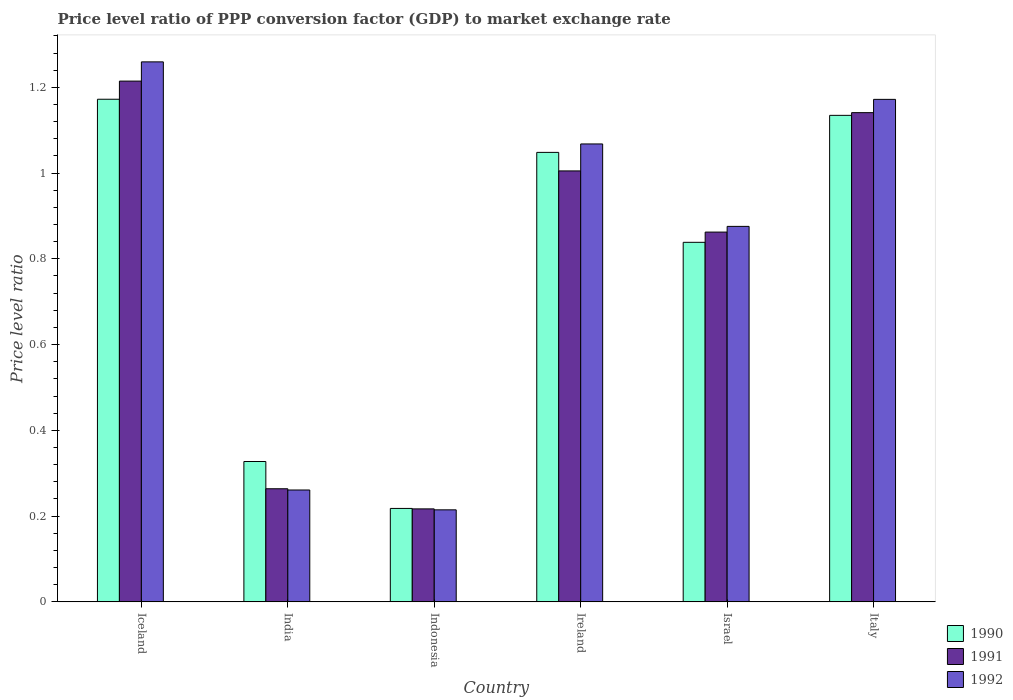How many groups of bars are there?
Provide a short and direct response. 6. Are the number of bars per tick equal to the number of legend labels?
Your response must be concise. Yes. Are the number of bars on each tick of the X-axis equal?
Your answer should be very brief. Yes. How many bars are there on the 4th tick from the right?
Offer a terse response. 3. What is the label of the 4th group of bars from the left?
Give a very brief answer. Ireland. In how many cases, is the number of bars for a given country not equal to the number of legend labels?
Provide a succinct answer. 0. What is the price level ratio in 1991 in Iceland?
Ensure brevity in your answer.  1.21. Across all countries, what is the maximum price level ratio in 1991?
Offer a very short reply. 1.21. Across all countries, what is the minimum price level ratio in 1991?
Provide a short and direct response. 0.22. In which country was the price level ratio in 1992 maximum?
Your response must be concise. Iceland. In which country was the price level ratio in 1992 minimum?
Your answer should be compact. Indonesia. What is the total price level ratio in 1990 in the graph?
Keep it short and to the point. 4.74. What is the difference between the price level ratio in 1991 in Indonesia and that in Ireland?
Make the answer very short. -0.79. What is the difference between the price level ratio in 1990 in Israel and the price level ratio in 1992 in Indonesia?
Your answer should be very brief. 0.62. What is the average price level ratio in 1992 per country?
Your answer should be very brief. 0.81. What is the difference between the price level ratio of/in 1992 and price level ratio of/in 1991 in Ireland?
Offer a terse response. 0.06. In how many countries, is the price level ratio in 1991 greater than 0.7200000000000001?
Offer a terse response. 4. What is the ratio of the price level ratio in 1990 in Ireland to that in Italy?
Offer a very short reply. 0.92. Is the price level ratio in 1991 in Ireland less than that in Italy?
Provide a short and direct response. Yes. What is the difference between the highest and the second highest price level ratio in 1992?
Offer a terse response. 0.19. What is the difference between the highest and the lowest price level ratio in 1992?
Make the answer very short. 1.04. In how many countries, is the price level ratio in 1990 greater than the average price level ratio in 1990 taken over all countries?
Make the answer very short. 4. What does the 2nd bar from the left in Iceland represents?
Provide a short and direct response. 1991. What does the 3rd bar from the right in Italy represents?
Offer a very short reply. 1990. Is it the case that in every country, the sum of the price level ratio in 1991 and price level ratio in 1992 is greater than the price level ratio in 1990?
Ensure brevity in your answer.  Yes. How many bars are there?
Your answer should be compact. 18. Are all the bars in the graph horizontal?
Make the answer very short. No. What is the difference between two consecutive major ticks on the Y-axis?
Your answer should be compact. 0.2. Are the values on the major ticks of Y-axis written in scientific E-notation?
Give a very brief answer. No. Does the graph contain grids?
Keep it short and to the point. No. How many legend labels are there?
Offer a very short reply. 3. How are the legend labels stacked?
Offer a terse response. Vertical. What is the title of the graph?
Keep it short and to the point. Price level ratio of PPP conversion factor (GDP) to market exchange rate. What is the label or title of the Y-axis?
Make the answer very short. Price level ratio. What is the Price level ratio of 1990 in Iceland?
Provide a short and direct response. 1.17. What is the Price level ratio of 1991 in Iceland?
Provide a short and direct response. 1.21. What is the Price level ratio in 1992 in Iceland?
Offer a very short reply. 1.26. What is the Price level ratio of 1990 in India?
Make the answer very short. 0.33. What is the Price level ratio in 1991 in India?
Offer a terse response. 0.26. What is the Price level ratio of 1992 in India?
Make the answer very short. 0.26. What is the Price level ratio in 1990 in Indonesia?
Your response must be concise. 0.22. What is the Price level ratio of 1991 in Indonesia?
Your response must be concise. 0.22. What is the Price level ratio of 1992 in Indonesia?
Provide a succinct answer. 0.21. What is the Price level ratio of 1990 in Ireland?
Give a very brief answer. 1.05. What is the Price level ratio in 1991 in Ireland?
Ensure brevity in your answer.  1.01. What is the Price level ratio of 1992 in Ireland?
Offer a very short reply. 1.07. What is the Price level ratio of 1990 in Israel?
Give a very brief answer. 0.84. What is the Price level ratio in 1991 in Israel?
Give a very brief answer. 0.86. What is the Price level ratio of 1992 in Israel?
Provide a succinct answer. 0.88. What is the Price level ratio of 1990 in Italy?
Provide a succinct answer. 1.13. What is the Price level ratio in 1991 in Italy?
Your answer should be very brief. 1.14. What is the Price level ratio of 1992 in Italy?
Your response must be concise. 1.17. Across all countries, what is the maximum Price level ratio of 1990?
Give a very brief answer. 1.17. Across all countries, what is the maximum Price level ratio in 1991?
Your answer should be very brief. 1.21. Across all countries, what is the maximum Price level ratio in 1992?
Keep it short and to the point. 1.26. Across all countries, what is the minimum Price level ratio in 1990?
Make the answer very short. 0.22. Across all countries, what is the minimum Price level ratio in 1991?
Keep it short and to the point. 0.22. Across all countries, what is the minimum Price level ratio of 1992?
Your answer should be compact. 0.21. What is the total Price level ratio of 1990 in the graph?
Provide a short and direct response. 4.74. What is the total Price level ratio of 1991 in the graph?
Your answer should be very brief. 4.7. What is the total Price level ratio in 1992 in the graph?
Provide a succinct answer. 4.85. What is the difference between the Price level ratio of 1990 in Iceland and that in India?
Keep it short and to the point. 0.84. What is the difference between the Price level ratio in 1991 in Iceland and that in India?
Offer a terse response. 0.95. What is the difference between the Price level ratio of 1992 in Iceland and that in India?
Ensure brevity in your answer.  1. What is the difference between the Price level ratio in 1990 in Iceland and that in Indonesia?
Make the answer very short. 0.95. What is the difference between the Price level ratio of 1992 in Iceland and that in Indonesia?
Make the answer very short. 1.04. What is the difference between the Price level ratio of 1990 in Iceland and that in Ireland?
Your response must be concise. 0.12. What is the difference between the Price level ratio in 1991 in Iceland and that in Ireland?
Keep it short and to the point. 0.21. What is the difference between the Price level ratio of 1992 in Iceland and that in Ireland?
Ensure brevity in your answer.  0.19. What is the difference between the Price level ratio in 1990 in Iceland and that in Israel?
Ensure brevity in your answer.  0.33. What is the difference between the Price level ratio in 1991 in Iceland and that in Israel?
Your answer should be very brief. 0.35. What is the difference between the Price level ratio in 1992 in Iceland and that in Israel?
Provide a succinct answer. 0.38. What is the difference between the Price level ratio of 1990 in Iceland and that in Italy?
Make the answer very short. 0.04. What is the difference between the Price level ratio of 1991 in Iceland and that in Italy?
Provide a short and direct response. 0.07. What is the difference between the Price level ratio in 1992 in Iceland and that in Italy?
Offer a very short reply. 0.09. What is the difference between the Price level ratio of 1990 in India and that in Indonesia?
Keep it short and to the point. 0.11. What is the difference between the Price level ratio of 1991 in India and that in Indonesia?
Your response must be concise. 0.05. What is the difference between the Price level ratio of 1992 in India and that in Indonesia?
Ensure brevity in your answer.  0.05. What is the difference between the Price level ratio of 1990 in India and that in Ireland?
Your answer should be very brief. -0.72. What is the difference between the Price level ratio of 1991 in India and that in Ireland?
Offer a very short reply. -0.74. What is the difference between the Price level ratio in 1992 in India and that in Ireland?
Your answer should be compact. -0.81. What is the difference between the Price level ratio in 1990 in India and that in Israel?
Keep it short and to the point. -0.51. What is the difference between the Price level ratio of 1991 in India and that in Israel?
Your answer should be very brief. -0.6. What is the difference between the Price level ratio of 1992 in India and that in Israel?
Provide a short and direct response. -0.61. What is the difference between the Price level ratio in 1990 in India and that in Italy?
Offer a very short reply. -0.81. What is the difference between the Price level ratio in 1991 in India and that in Italy?
Give a very brief answer. -0.88. What is the difference between the Price level ratio in 1992 in India and that in Italy?
Make the answer very short. -0.91. What is the difference between the Price level ratio in 1990 in Indonesia and that in Ireland?
Your answer should be very brief. -0.83. What is the difference between the Price level ratio in 1991 in Indonesia and that in Ireland?
Give a very brief answer. -0.79. What is the difference between the Price level ratio in 1992 in Indonesia and that in Ireland?
Offer a very short reply. -0.85. What is the difference between the Price level ratio in 1990 in Indonesia and that in Israel?
Offer a very short reply. -0.62. What is the difference between the Price level ratio of 1991 in Indonesia and that in Israel?
Keep it short and to the point. -0.65. What is the difference between the Price level ratio of 1992 in Indonesia and that in Israel?
Your answer should be very brief. -0.66. What is the difference between the Price level ratio in 1990 in Indonesia and that in Italy?
Give a very brief answer. -0.92. What is the difference between the Price level ratio in 1991 in Indonesia and that in Italy?
Keep it short and to the point. -0.92. What is the difference between the Price level ratio in 1992 in Indonesia and that in Italy?
Keep it short and to the point. -0.96. What is the difference between the Price level ratio in 1990 in Ireland and that in Israel?
Make the answer very short. 0.21. What is the difference between the Price level ratio of 1991 in Ireland and that in Israel?
Offer a terse response. 0.14. What is the difference between the Price level ratio in 1992 in Ireland and that in Israel?
Offer a very short reply. 0.19. What is the difference between the Price level ratio of 1990 in Ireland and that in Italy?
Offer a very short reply. -0.09. What is the difference between the Price level ratio of 1991 in Ireland and that in Italy?
Give a very brief answer. -0.14. What is the difference between the Price level ratio of 1992 in Ireland and that in Italy?
Provide a succinct answer. -0.1. What is the difference between the Price level ratio of 1990 in Israel and that in Italy?
Ensure brevity in your answer.  -0.3. What is the difference between the Price level ratio of 1991 in Israel and that in Italy?
Keep it short and to the point. -0.28. What is the difference between the Price level ratio of 1992 in Israel and that in Italy?
Offer a terse response. -0.3. What is the difference between the Price level ratio in 1990 in Iceland and the Price level ratio in 1991 in India?
Offer a terse response. 0.91. What is the difference between the Price level ratio in 1990 in Iceland and the Price level ratio in 1992 in India?
Offer a terse response. 0.91. What is the difference between the Price level ratio in 1991 in Iceland and the Price level ratio in 1992 in India?
Provide a short and direct response. 0.95. What is the difference between the Price level ratio of 1990 in Iceland and the Price level ratio of 1991 in Indonesia?
Provide a short and direct response. 0.96. What is the difference between the Price level ratio in 1990 in Iceland and the Price level ratio in 1992 in Indonesia?
Ensure brevity in your answer.  0.96. What is the difference between the Price level ratio of 1991 in Iceland and the Price level ratio of 1992 in Indonesia?
Provide a succinct answer. 1. What is the difference between the Price level ratio of 1990 in Iceland and the Price level ratio of 1991 in Ireland?
Your answer should be compact. 0.17. What is the difference between the Price level ratio in 1990 in Iceland and the Price level ratio in 1992 in Ireland?
Give a very brief answer. 0.1. What is the difference between the Price level ratio of 1991 in Iceland and the Price level ratio of 1992 in Ireland?
Your answer should be compact. 0.15. What is the difference between the Price level ratio of 1990 in Iceland and the Price level ratio of 1991 in Israel?
Your answer should be compact. 0.31. What is the difference between the Price level ratio of 1990 in Iceland and the Price level ratio of 1992 in Israel?
Ensure brevity in your answer.  0.3. What is the difference between the Price level ratio in 1991 in Iceland and the Price level ratio in 1992 in Israel?
Ensure brevity in your answer.  0.34. What is the difference between the Price level ratio of 1990 in Iceland and the Price level ratio of 1991 in Italy?
Your answer should be compact. 0.03. What is the difference between the Price level ratio of 1990 in Iceland and the Price level ratio of 1992 in Italy?
Make the answer very short. 0. What is the difference between the Price level ratio of 1991 in Iceland and the Price level ratio of 1992 in Italy?
Make the answer very short. 0.04. What is the difference between the Price level ratio in 1990 in India and the Price level ratio in 1991 in Indonesia?
Offer a very short reply. 0.11. What is the difference between the Price level ratio of 1990 in India and the Price level ratio of 1992 in Indonesia?
Provide a short and direct response. 0.11. What is the difference between the Price level ratio of 1991 in India and the Price level ratio of 1992 in Indonesia?
Provide a succinct answer. 0.05. What is the difference between the Price level ratio of 1990 in India and the Price level ratio of 1991 in Ireland?
Provide a short and direct response. -0.68. What is the difference between the Price level ratio of 1990 in India and the Price level ratio of 1992 in Ireland?
Offer a very short reply. -0.74. What is the difference between the Price level ratio in 1991 in India and the Price level ratio in 1992 in Ireland?
Your response must be concise. -0.8. What is the difference between the Price level ratio in 1990 in India and the Price level ratio in 1991 in Israel?
Make the answer very short. -0.54. What is the difference between the Price level ratio of 1990 in India and the Price level ratio of 1992 in Israel?
Keep it short and to the point. -0.55. What is the difference between the Price level ratio of 1991 in India and the Price level ratio of 1992 in Israel?
Your response must be concise. -0.61. What is the difference between the Price level ratio in 1990 in India and the Price level ratio in 1991 in Italy?
Your response must be concise. -0.81. What is the difference between the Price level ratio of 1990 in India and the Price level ratio of 1992 in Italy?
Give a very brief answer. -0.84. What is the difference between the Price level ratio in 1991 in India and the Price level ratio in 1992 in Italy?
Your answer should be compact. -0.91. What is the difference between the Price level ratio of 1990 in Indonesia and the Price level ratio of 1991 in Ireland?
Provide a short and direct response. -0.79. What is the difference between the Price level ratio in 1990 in Indonesia and the Price level ratio in 1992 in Ireland?
Your answer should be very brief. -0.85. What is the difference between the Price level ratio of 1991 in Indonesia and the Price level ratio of 1992 in Ireland?
Your response must be concise. -0.85. What is the difference between the Price level ratio in 1990 in Indonesia and the Price level ratio in 1991 in Israel?
Your answer should be compact. -0.64. What is the difference between the Price level ratio in 1990 in Indonesia and the Price level ratio in 1992 in Israel?
Your response must be concise. -0.66. What is the difference between the Price level ratio of 1991 in Indonesia and the Price level ratio of 1992 in Israel?
Offer a very short reply. -0.66. What is the difference between the Price level ratio in 1990 in Indonesia and the Price level ratio in 1991 in Italy?
Your answer should be very brief. -0.92. What is the difference between the Price level ratio of 1990 in Indonesia and the Price level ratio of 1992 in Italy?
Provide a succinct answer. -0.95. What is the difference between the Price level ratio in 1991 in Indonesia and the Price level ratio in 1992 in Italy?
Your response must be concise. -0.95. What is the difference between the Price level ratio in 1990 in Ireland and the Price level ratio in 1991 in Israel?
Your answer should be compact. 0.19. What is the difference between the Price level ratio in 1990 in Ireland and the Price level ratio in 1992 in Israel?
Provide a succinct answer. 0.17. What is the difference between the Price level ratio in 1991 in Ireland and the Price level ratio in 1992 in Israel?
Give a very brief answer. 0.13. What is the difference between the Price level ratio in 1990 in Ireland and the Price level ratio in 1991 in Italy?
Ensure brevity in your answer.  -0.09. What is the difference between the Price level ratio of 1990 in Ireland and the Price level ratio of 1992 in Italy?
Provide a short and direct response. -0.12. What is the difference between the Price level ratio in 1991 in Ireland and the Price level ratio in 1992 in Italy?
Make the answer very short. -0.17. What is the difference between the Price level ratio in 1990 in Israel and the Price level ratio in 1991 in Italy?
Provide a short and direct response. -0.3. What is the difference between the Price level ratio of 1990 in Israel and the Price level ratio of 1992 in Italy?
Offer a very short reply. -0.33. What is the difference between the Price level ratio in 1991 in Israel and the Price level ratio in 1992 in Italy?
Make the answer very short. -0.31. What is the average Price level ratio of 1990 per country?
Ensure brevity in your answer.  0.79. What is the average Price level ratio in 1991 per country?
Give a very brief answer. 0.78. What is the average Price level ratio of 1992 per country?
Offer a terse response. 0.81. What is the difference between the Price level ratio in 1990 and Price level ratio in 1991 in Iceland?
Give a very brief answer. -0.04. What is the difference between the Price level ratio of 1990 and Price level ratio of 1992 in Iceland?
Provide a succinct answer. -0.09. What is the difference between the Price level ratio of 1991 and Price level ratio of 1992 in Iceland?
Your response must be concise. -0.04. What is the difference between the Price level ratio in 1990 and Price level ratio in 1991 in India?
Provide a succinct answer. 0.06. What is the difference between the Price level ratio in 1990 and Price level ratio in 1992 in India?
Keep it short and to the point. 0.07. What is the difference between the Price level ratio of 1991 and Price level ratio of 1992 in India?
Offer a terse response. 0. What is the difference between the Price level ratio in 1990 and Price level ratio in 1991 in Indonesia?
Give a very brief answer. 0. What is the difference between the Price level ratio in 1990 and Price level ratio in 1992 in Indonesia?
Give a very brief answer. 0. What is the difference between the Price level ratio of 1991 and Price level ratio of 1992 in Indonesia?
Your response must be concise. 0. What is the difference between the Price level ratio of 1990 and Price level ratio of 1991 in Ireland?
Give a very brief answer. 0.04. What is the difference between the Price level ratio of 1990 and Price level ratio of 1992 in Ireland?
Your answer should be compact. -0.02. What is the difference between the Price level ratio of 1991 and Price level ratio of 1992 in Ireland?
Your answer should be very brief. -0.06. What is the difference between the Price level ratio in 1990 and Price level ratio in 1991 in Israel?
Your response must be concise. -0.02. What is the difference between the Price level ratio in 1990 and Price level ratio in 1992 in Israel?
Your answer should be compact. -0.04. What is the difference between the Price level ratio in 1991 and Price level ratio in 1992 in Israel?
Provide a short and direct response. -0.01. What is the difference between the Price level ratio of 1990 and Price level ratio of 1991 in Italy?
Offer a very short reply. -0.01. What is the difference between the Price level ratio of 1990 and Price level ratio of 1992 in Italy?
Your response must be concise. -0.04. What is the difference between the Price level ratio of 1991 and Price level ratio of 1992 in Italy?
Your response must be concise. -0.03. What is the ratio of the Price level ratio of 1990 in Iceland to that in India?
Ensure brevity in your answer.  3.58. What is the ratio of the Price level ratio in 1991 in Iceland to that in India?
Keep it short and to the point. 4.6. What is the ratio of the Price level ratio in 1992 in Iceland to that in India?
Your answer should be very brief. 4.83. What is the ratio of the Price level ratio of 1990 in Iceland to that in Indonesia?
Provide a succinct answer. 5.38. What is the ratio of the Price level ratio of 1991 in Iceland to that in Indonesia?
Your response must be concise. 5.6. What is the ratio of the Price level ratio in 1992 in Iceland to that in Indonesia?
Offer a very short reply. 5.87. What is the ratio of the Price level ratio of 1990 in Iceland to that in Ireland?
Your answer should be very brief. 1.12. What is the ratio of the Price level ratio in 1991 in Iceland to that in Ireland?
Your answer should be very brief. 1.21. What is the ratio of the Price level ratio of 1992 in Iceland to that in Ireland?
Provide a succinct answer. 1.18. What is the ratio of the Price level ratio of 1990 in Iceland to that in Israel?
Offer a terse response. 1.4. What is the ratio of the Price level ratio in 1991 in Iceland to that in Israel?
Ensure brevity in your answer.  1.41. What is the ratio of the Price level ratio of 1992 in Iceland to that in Israel?
Give a very brief answer. 1.44. What is the ratio of the Price level ratio in 1990 in Iceland to that in Italy?
Offer a very short reply. 1.03. What is the ratio of the Price level ratio of 1991 in Iceland to that in Italy?
Make the answer very short. 1.06. What is the ratio of the Price level ratio of 1992 in Iceland to that in Italy?
Offer a very short reply. 1.07. What is the ratio of the Price level ratio in 1990 in India to that in Indonesia?
Keep it short and to the point. 1.5. What is the ratio of the Price level ratio of 1991 in India to that in Indonesia?
Make the answer very short. 1.22. What is the ratio of the Price level ratio in 1992 in India to that in Indonesia?
Your response must be concise. 1.22. What is the ratio of the Price level ratio in 1990 in India to that in Ireland?
Provide a succinct answer. 0.31. What is the ratio of the Price level ratio of 1991 in India to that in Ireland?
Your answer should be very brief. 0.26. What is the ratio of the Price level ratio in 1992 in India to that in Ireland?
Provide a short and direct response. 0.24. What is the ratio of the Price level ratio in 1990 in India to that in Israel?
Offer a very short reply. 0.39. What is the ratio of the Price level ratio in 1991 in India to that in Israel?
Keep it short and to the point. 0.31. What is the ratio of the Price level ratio in 1992 in India to that in Israel?
Provide a succinct answer. 0.3. What is the ratio of the Price level ratio of 1990 in India to that in Italy?
Provide a succinct answer. 0.29. What is the ratio of the Price level ratio in 1991 in India to that in Italy?
Your response must be concise. 0.23. What is the ratio of the Price level ratio in 1992 in India to that in Italy?
Ensure brevity in your answer.  0.22. What is the ratio of the Price level ratio in 1990 in Indonesia to that in Ireland?
Offer a terse response. 0.21. What is the ratio of the Price level ratio in 1991 in Indonesia to that in Ireland?
Make the answer very short. 0.22. What is the ratio of the Price level ratio of 1992 in Indonesia to that in Ireland?
Provide a succinct answer. 0.2. What is the ratio of the Price level ratio of 1990 in Indonesia to that in Israel?
Your response must be concise. 0.26. What is the ratio of the Price level ratio of 1991 in Indonesia to that in Israel?
Ensure brevity in your answer.  0.25. What is the ratio of the Price level ratio in 1992 in Indonesia to that in Israel?
Give a very brief answer. 0.25. What is the ratio of the Price level ratio of 1990 in Indonesia to that in Italy?
Your answer should be compact. 0.19. What is the ratio of the Price level ratio of 1991 in Indonesia to that in Italy?
Ensure brevity in your answer.  0.19. What is the ratio of the Price level ratio in 1992 in Indonesia to that in Italy?
Offer a very short reply. 0.18. What is the ratio of the Price level ratio in 1990 in Ireland to that in Israel?
Your answer should be compact. 1.25. What is the ratio of the Price level ratio in 1991 in Ireland to that in Israel?
Make the answer very short. 1.17. What is the ratio of the Price level ratio of 1992 in Ireland to that in Israel?
Provide a short and direct response. 1.22. What is the ratio of the Price level ratio of 1990 in Ireland to that in Italy?
Provide a succinct answer. 0.92. What is the ratio of the Price level ratio of 1991 in Ireland to that in Italy?
Your answer should be very brief. 0.88. What is the ratio of the Price level ratio of 1992 in Ireland to that in Italy?
Provide a short and direct response. 0.91. What is the ratio of the Price level ratio in 1990 in Israel to that in Italy?
Offer a very short reply. 0.74. What is the ratio of the Price level ratio in 1991 in Israel to that in Italy?
Make the answer very short. 0.76. What is the ratio of the Price level ratio of 1992 in Israel to that in Italy?
Keep it short and to the point. 0.75. What is the difference between the highest and the second highest Price level ratio in 1990?
Provide a succinct answer. 0.04. What is the difference between the highest and the second highest Price level ratio in 1991?
Provide a short and direct response. 0.07. What is the difference between the highest and the second highest Price level ratio in 1992?
Ensure brevity in your answer.  0.09. What is the difference between the highest and the lowest Price level ratio in 1990?
Your response must be concise. 0.95. What is the difference between the highest and the lowest Price level ratio of 1992?
Your answer should be compact. 1.04. 